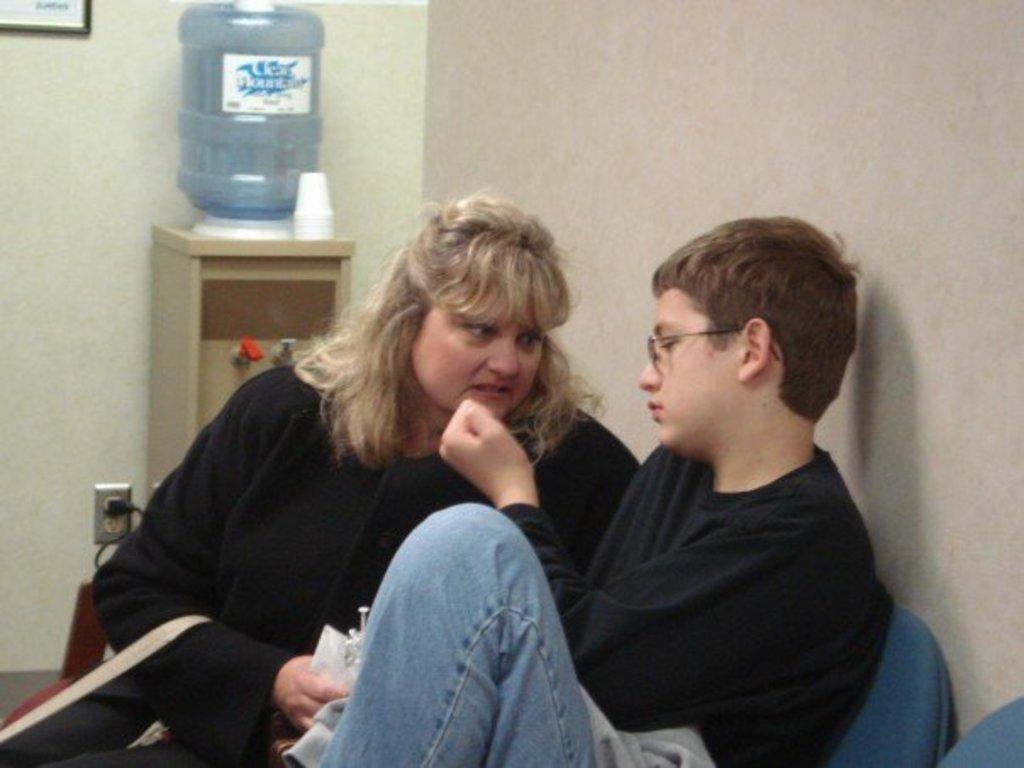Who are the people in the image? There is a lady and a boy in the image. What are the lady and the boy doing in the image? Both the lady and the boy are sitting on chairs. What can be seen on the table in the image? There is a water filter and glasses on the table in the image. What is hanging on the wall in the image? There is a photo frame on the wall in the image. What type of trade is being conducted in the image? There is no indication of any trade being conducted in the image; it features a lady and a boy sitting on chairs, a water filter and glasses on a table, and a photo frame on the wall. 